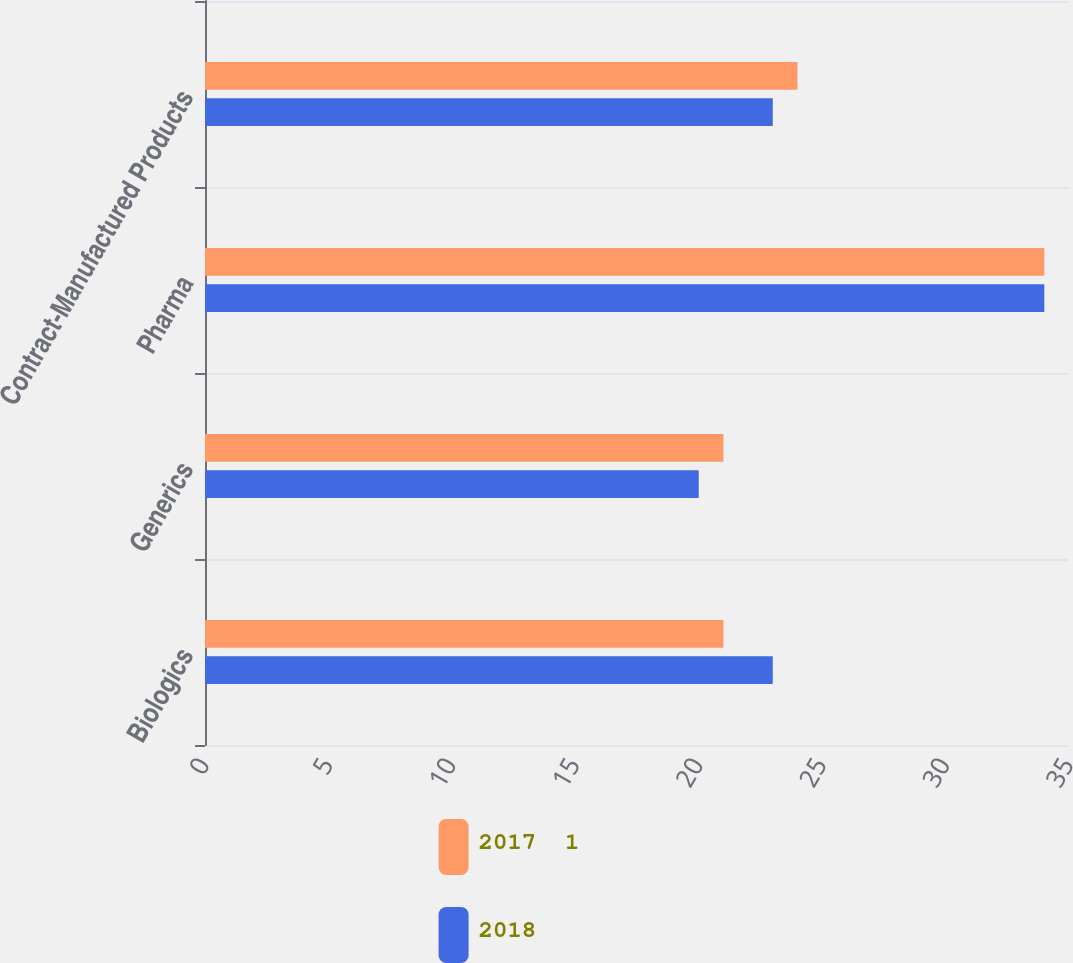<chart> <loc_0><loc_0><loc_500><loc_500><stacked_bar_chart><ecel><fcel>Biologics<fcel>Generics<fcel>Pharma<fcel>Contract-Manufactured Products<nl><fcel>2017  1<fcel>21<fcel>21<fcel>34<fcel>24<nl><fcel>2018<fcel>23<fcel>20<fcel>34<fcel>23<nl></chart> 